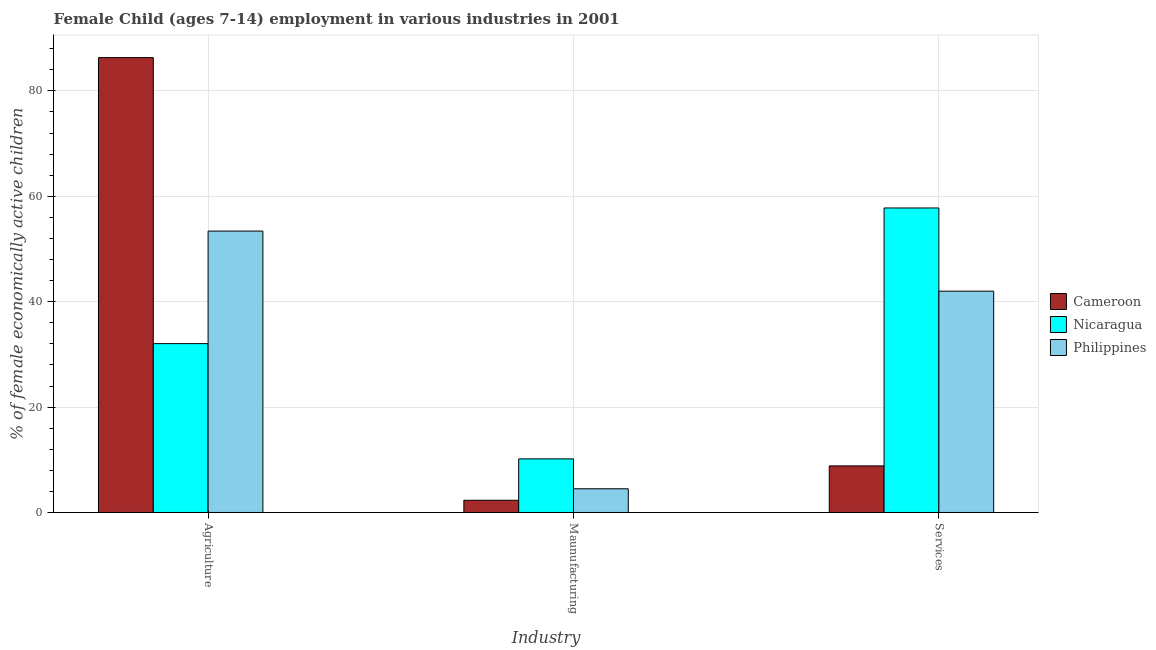How many different coloured bars are there?
Make the answer very short. 3. How many groups of bars are there?
Offer a very short reply. 3. Are the number of bars on each tick of the X-axis equal?
Your response must be concise. Yes. What is the label of the 3rd group of bars from the left?
Make the answer very short. Services. Across all countries, what is the maximum percentage of economically active children in manufacturing?
Make the answer very short. 10.17. Across all countries, what is the minimum percentage of economically active children in manufacturing?
Your response must be concise. 2.32. In which country was the percentage of economically active children in services maximum?
Your answer should be compact. Nicaragua. In which country was the percentage of economically active children in manufacturing minimum?
Your answer should be very brief. Cameroon. What is the total percentage of economically active children in services in the graph?
Keep it short and to the point. 108.63. What is the difference between the percentage of economically active children in services in Cameroon and that in Philippines?
Provide a short and direct response. -33.16. What is the difference between the percentage of economically active children in manufacturing in Nicaragua and the percentage of economically active children in services in Cameroon?
Your answer should be compact. 1.33. What is the average percentage of economically active children in services per country?
Your answer should be very brief. 36.21. What is the difference between the percentage of economically active children in agriculture and percentage of economically active children in manufacturing in Philippines?
Your answer should be compact. 48.9. In how many countries, is the percentage of economically active children in manufacturing greater than 12 %?
Offer a terse response. 0. What is the ratio of the percentage of economically active children in manufacturing in Philippines to that in Nicaragua?
Your answer should be very brief. 0.44. Is the percentage of economically active children in services in Cameroon less than that in Nicaragua?
Keep it short and to the point. Yes. What is the difference between the highest and the second highest percentage of economically active children in agriculture?
Provide a succinct answer. 32.92. What is the difference between the highest and the lowest percentage of economically active children in services?
Make the answer very short. 48.95. Is the sum of the percentage of economically active children in agriculture in Philippines and Nicaragua greater than the maximum percentage of economically active children in manufacturing across all countries?
Provide a succinct answer. Yes. What does the 3rd bar from the left in Maunufacturing represents?
Your answer should be very brief. Philippines. What does the 3rd bar from the right in Services represents?
Offer a very short reply. Cameroon. How many countries are there in the graph?
Your answer should be compact. 3. What is the difference between two consecutive major ticks on the Y-axis?
Your answer should be compact. 20. Does the graph contain grids?
Keep it short and to the point. Yes. Where does the legend appear in the graph?
Provide a succinct answer. Center right. What is the title of the graph?
Offer a terse response. Female Child (ages 7-14) employment in various industries in 2001. Does "Romania" appear as one of the legend labels in the graph?
Ensure brevity in your answer.  No. What is the label or title of the X-axis?
Make the answer very short. Industry. What is the label or title of the Y-axis?
Your answer should be compact. % of female economically active children. What is the % of female economically active children of Cameroon in Agriculture?
Offer a very short reply. 86.32. What is the % of female economically active children of Nicaragua in Agriculture?
Your answer should be compact. 32.04. What is the % of female economically active children of Philippines in Agriculture?
Give a very brief answer. 53.4. What is the % of female economically active children in Cameroon in Maunufacturing?
Keep it short and to the point. 2.32. What is the % of female economically active children of Nicaragua in Maunufacturing?
Your answer should be compact. 10.17. What is the % of female economically active children of Cameroon in Services?
Your response must be concise. 8.84. What is the % of female economically active children in Nicaragua in Services?
Your answer should be compact. 57.79. What is the % of female economically active children in Philippines in Services?
Make the answer very short. 42. Across all Industry, what is the maximum % of female economically active children of Cameroon?
Your answer should be very brief. 86.32. Across all Industry, what is the maximum % of female economically active children in Nicaragua?
Offer a terse response. 57.79. Across all Industry, what is the maximum % of female economically active children in Philippines?
Provide a short and direct response. 53.4. Across all Industry, what is the minimum % of female economically active children of Cameroon?
Ensure brevity in your answer.  2.32. Across all Industry, what is the minimum % of female economically active children of Nicaragua?
Provide a short and direct response. 10.17. What is the total % of female economically active children of Cameroon in the graph?
Offer a very short reply. 97.48. What is the total % of female economically active children of Nicaragua in the graph?
Provide a succinct answer. 100. What is the total % of female economically active children in Philippines in the graph?
Keep it short and to the point. 99.9. What is the difference between the % of female economically active children in Nicaragua in Agriculture and that in Maunufacturing?
Your answer should be very brief. 21.87. What is the difference between the % of female economically active children of Philippines in Agriculture and that in Maunufacturing?
Your answer should be compact. 48.9. What is the difference between the % of female economically active children in Cameroon in Agriculture and that in Services?
Ensure brevity in your answer.  77.48. What is the difference between the % of female economically active children of Nicaragua in Agriculture and that in Services?
Ensure brevity in your answer.  -25.74. What is the difference between the % of female economically active children in Philippines in Agriculture and that in Services?
Your answer should be very brief. 11.4. What is the difference between the % of female economically active children of Cameroon in Maunufacturing and that in Services?
Your answer should be compact. -6.52. What is the difference between the % of female economically active children of Nicaragua in Maunufacturing and that in Services?
Keep it short and to the point. -47.61. What is the difference between the % of female economically active children in Philippines in Maunufacturing and that in Services?
Ensure brevity in your answer.  -37.5. What is the difference between the % of female economically active children of Cameroon in Agriculture and the % of female economically active children of Nicaragua in Maunufacturing?
Offer a very short reply. 76.15. What is the difference between the % of female economically active children of Cameroon in Agriculture and the % of female economically active children of Philippines in Maunufacturing?
Make the answer very short. 81.82. What is the difference between the % of female economically active children of Nicaragua in Agriculture and the % of female economically active children of Philippines in Maunufacturing?
Your response must be concise. 27.54. What is the difference between the % of female economically active children of Cameroon in Agriculture and the % of female economically active children of Nicaragua in Services?
Provide a succinct answer. 28.53. What is the difference between the % of female economically active children of Cameroon in Agriculture and the % of female economically active children of Philippines in Services?
Offer a terse response. 44.32. What is the difference between the % of female economically active children in Nicaragua in Agriculture and the % of female economically active children in Philippines in Services?
Provide a short and direct response. -9.96. What is the difference between the % of female economically active children of Cameroon in Maunufacturing and the % of female economically active children of Nicaragua in Services?
Provide a succinct answer. -55.47. What is the difference between the % of female economically active children in Cameroon in Maunufacturing and the % of female economically active children in Philippines in Services?
Offer a very short reply. -39.68. What is the difference between the % of female economically active children in Nicaragua in Maunufacturing and the % of female economically active children in Philippines in Services?
Keep it short and to the point. -31.83. What is the average % of female economically active children in Cameroon per Industry?
Your answer should be very brief. 32.49. What is the average % of female economically active children in Nicaragua per Industry?
Offer a terse response. 33.33. What is the average % of female economically active children of Philippines per Industry?
Give a very brief answer. 33.3. What is the difference between the % of female economically active children of Cameroon and % of female economically active children of Nicaragua in Agriculture?
Provide a succinct answer. 54.28. What is the difference between the % of female economically active children in Cameroon and % of female economically active children in Philippines in Agriculture?
Provide a succinct answer. 32.92. What is the difference between the % of female economically active children of Nicaragua and % of female economically active children of Philippines in Agriculture?
Keep it short and to the point. -21.36. What is the difference between the % of female economically active children of Cameroon and % of female economically active children of Nicaragua in Maunufacturing?
Your response must be concise. -7.85. What is the difference between the % of female economically active children in Cameroon and % of female economically active children in Philippines in Maunufacturing?
Offer a very short reply. -2.18. What is the difference between the % of female economically active children in Nicaragua and % of female economically active children in Philippines in Maunufacturing?
Keep it short and to the point. 5.67. What is the difference between the % of female economically active children in Cameroon and % of female economically active children in Nicaragua in Services?
Offer a very short reply. -48.95. What is the difference between the % of female economically active children in Cameroon and % of female economically active children in Philippines in Services?
Provide a short and direct response. -33.16. What is the difference between the % of female economically active children of Nicaragua and % of female economically active children of Philippines in Services?
Your answer should be compact. 15.79. What is the ratio of the % of female economically active children in Cameroon in Agriculture to that in Maunufacturing?
Your answer should be very brief. 37.21. What is the ratio of the % of female economically active children in Nicaragua in Agriculture to that in Maunufacturing?
Ensure brevity in your answer.  3.15. What is the ratio of the % of female economically active children of Philippines in Agriculture to that in Maunufacturing?
Your response must be concise. 11.87. What is the ratio of the % of female economically active children in Cameroon in Agriculture to that in Services?
Provide a short and direct response. 9.76. What is the ratio of the % of female economically active children in Nicaragua in Agriculture to that in Services?
Keep it short and to the point. 0.55. What is the ratio of the % of female economically active children in Philippines in Agriculture to that in Services?
Give a very brief answer. 1.27. What is the ratio of the % of female economically active children of Cameroon in Maunufacturing to that in Services?
Your answer should be very brief. 0.26. What is the ratio of the % of female economically active children in Nicaragua in Maunufacturing to that in Services?
Ensure brevity in your answer.  0.18. What is the ratio of the % of female economically active children in Philippines in Maunufacturing to that in Services?
Ensure brevity in your answer.  0.11. What is the difference between the highest and the second highest % of female economically active children of Cameroon?
Your answer should be very brief. 77.48. What is the difference between the highest and the second highest % of female economically active children in Nicaragua?
Offer a very short reply. 25.74. What is the difference between the highest and the lowest % of female economically active children in Cameroon?
Your answer should be very brief. 84. What is the difference between the highest and the lowest % of female economically active children of Nicaragua?
Offer a very short reply. 47.61. What is the difference between the highest and the lowest % of female economically active children of Philippines?
Offer a terse response. 48.9. 